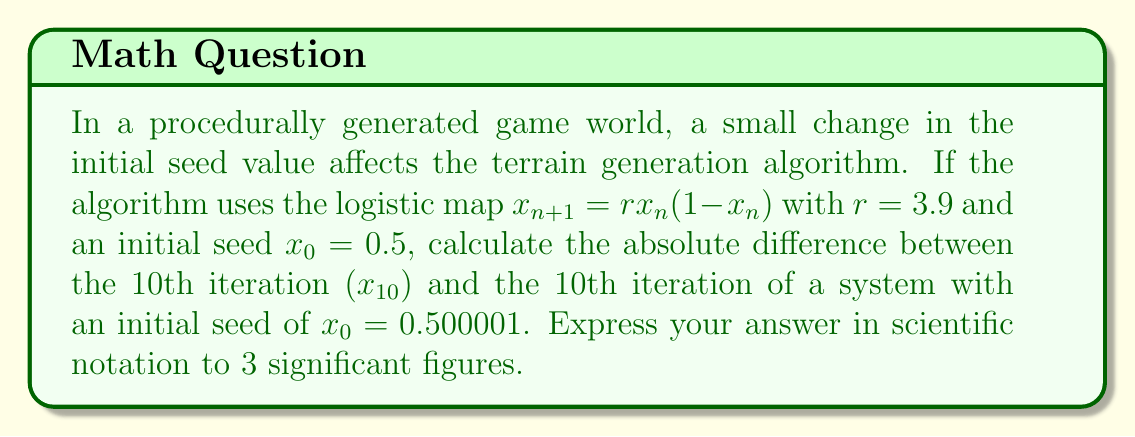Solve this math problem. To solve this problem, we need to iterate the logistic map for both initial conditions and compare the results. Let's break it down step-by-step:

1. Define the logistic map: $x_{n+1} = rx_n(1-x_n)$ with $r = 3.9$

2. For the first system (A), $x_0 = 0.5$
   For the second system (B), $x_0 = 0.500001$

3. Iterate both systems 10 times:

   System A:
   $x_1 = 3.9 \cdot 0.5 \cdot (1-0.5) = 0.975$
   $x_2 = 3.9 \cdot 0.975 \cdot (1-0.975) = 0.0950625$
   ...
   $x_{10} = 0.8909511546$

   System B:
   $x_1 = 3.9 \cdot 0.500001 \cdot (1-0.500001) = 0.9750019499$
   $x_2 = 3.9 \cdot 0.9750019499 \cdot (1-0.9750019499) = 0.0950571380$
   ...
   $x_{10} = 0.5450414457$

4. Calculate the absolute difference:
   $|\text{A} - \text{B}| = |0.8909511546 - 0.5450414457| = 0.3459097089$

5. Express the result in scientific notation to 3 significant figures:
   $0.3459097089 \approx 3.46 \times 10^{-1}$

This demonstrates the butterfly effect in the game's procedural generation system, where a tiny change in the initial condition leads to a significant difference after only 10 iterations.
Answer: $3.46 \times 10^{-1}$ 